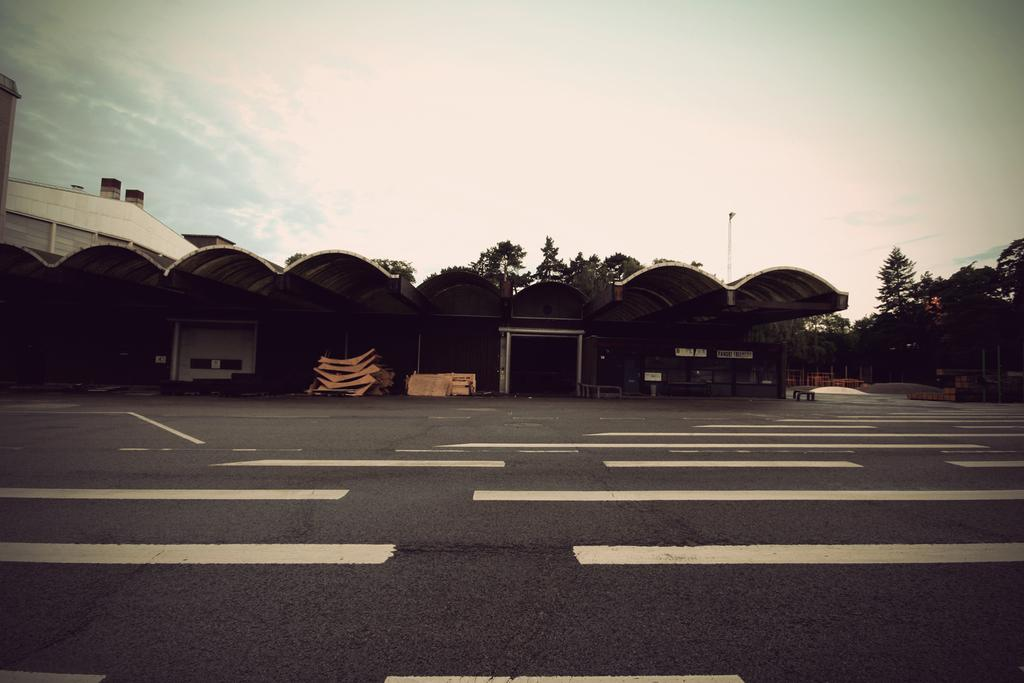What type of pathway is visible in the image? There is a road in the image. What wooden structures can be seen in the image? The wooden objects resemble a shed. What type of structure is present in the image? There is a building in the image. What type of vegetation is visible in the image? There are trees in the image. What part of the natural environment is visible in the image? The sky is visible in the background of the image. What type of pleasure can be seen enjoying the queen's presence in the image? There is no reference to pleasure, a queen, or any people in the image; it features a road, a shed, a building, trees, and the sky. What type of airport is visible in the image? There is no airport present in the image; it features a road, a shed, a building, trees, and the sky. 